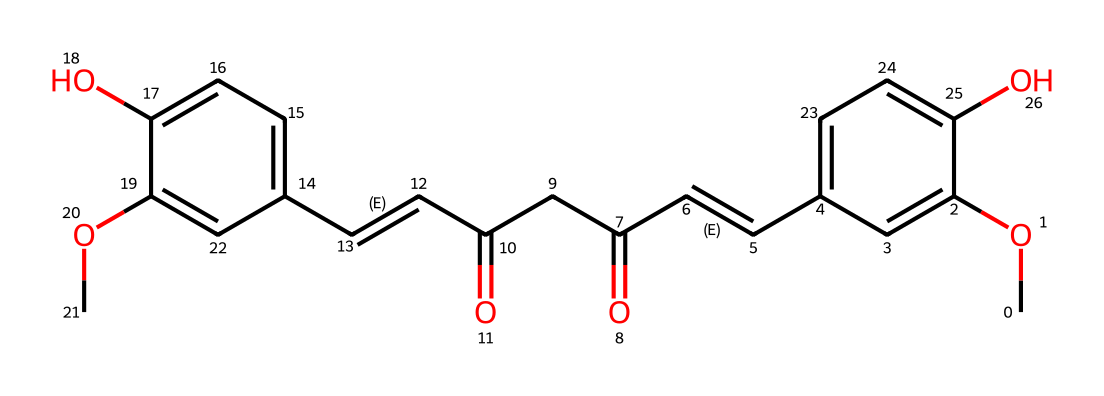What is the molecular formula of curcumin? The molecular formula can be derived by counting all the atoms represented in the SMILES notation. Here, we find carbon (C), hydrogen (H), and oxygen (O). The total is C21H20O6.
Answer: C21H20O6 How many carbon atoms are in the structure of curcumin? Counting the carbon ('C') symbols in the SMILES string shows there are 21 carbon atoms present in the compound.
Answer: 21 What type of functional groups are present in curcumin? The SMILES indicates the presence of hydroxyl groups (–OH) and methoxy groups (–OCH3) among other structures. Thus, the main functional groups identified are phenolic and methoxy.
Answer: phenolic, methoxy What is the main structural feature that indicates that curcumin is a diketone? There are two carbonyl groups (C=O) in the structure, which are characteristic of diketones. These can be identified in the sequence containing "C(=O)" in the SMILES.
Answer: two carbonyl groups How is the curcumin structure related to its anti-inflammatory properties? Curcumin's structure contains multiple conjugated double bonds and hydroxyl groups, which contribute to its antioxidant activity and ability to inhibit inflammation at the molecular level. This results from the electron delocalization and potential hydrogen bonding ability associated with these features.
Answer: conjugated double bonds and hydroxyl groups What indicates that curcumin is a polyphenolic compound? The presence of multiple hydroxyl groups (-OH) attached to aromatic rings indicates that curcumin is a polyphenolic compound. This can be seen in the sections of the structure featuring multiple -OH groups attached to the phenolic compounds.
Answer: multiple hydroxyl groups 